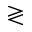<formula> <loc_0><loc_0><loc_500><loc_500>\gtrless</formula> 